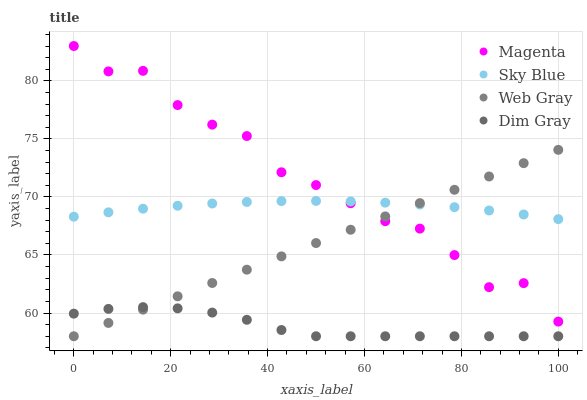Does Dim Gray have the minimum area under the curve?
Answer yes or no. Yes. Does Magenta have the maximum area under the curve?
Answer yes or no. Yes. Does Web Gray have the minimum area under the curve?
Answer yes or no. No. Does Web Gray have the maximum area under the curve?
Answer yes or no. No. Is Web Gray the smoothest?
Answer yes or no. Yes. Is Magenta the roughest?
Answer yes or no. Yes. Is Magenta the smoothest?
Answer yes or no. No. Is Web Gray the roughest?
Answer yes or no. No. Does Web Gray have the lowest value?
Answer yes or no. Yes. Does Magenta have the lowest value?
Answer yes or no. No. Does Magenta have the highest value?
Answer yes or no. Yes. Does Web Gray have the highest value?
Answer yes or no. No. Is Dim Gray less than Magenta?
Answer yes or no. Yes. Is Sky Blue greater than Dim Gray?
Answer yes or no. Yes. Does Dim Gray intersect Web Gray?
Answer yes or no. Yes. Is Dim Gray less than Web Gray?
Answer yes or no. No. Is Dim Gray greater than Web Gray?
Answer yes or no. No. Does Dim Gray intersect Magenta?
Answer yes or no. No. 